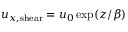Convert formula to latex. <formula><loc_0><loc_0><loc_500><loc_500>u _ { x , s h e a r } = u _ { 0 } \exp ( z / \beta )</formula> 